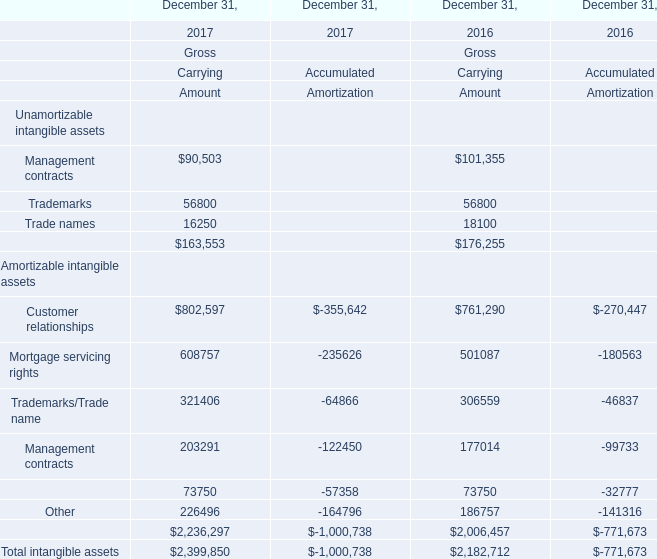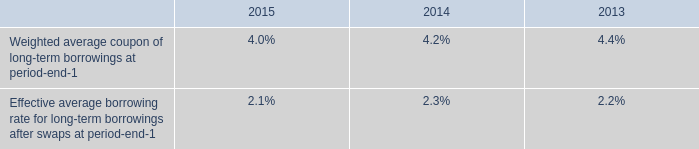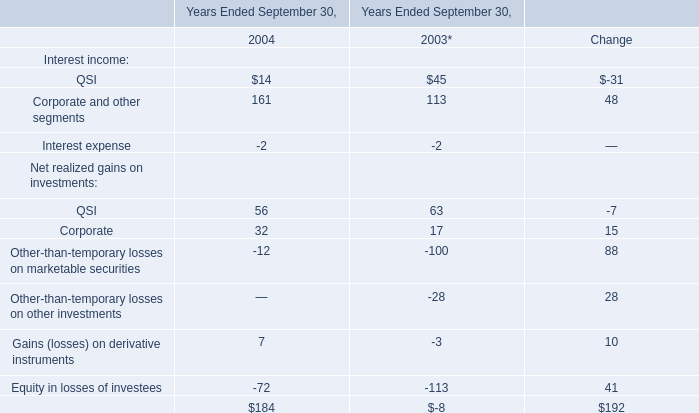What is the percentage of all Unamortizable intangible assets that are positive to the total amount, in 2017? (in thousand) 
Computations: (163553 / 2399850)
Answer: 0.06815. 